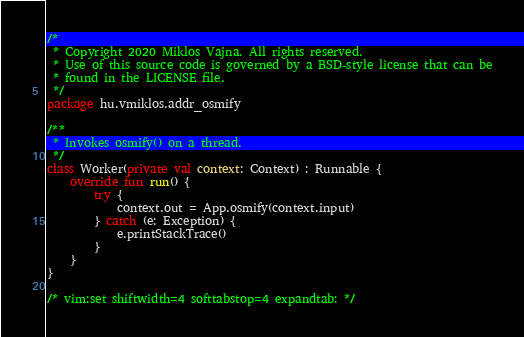<code> <loc_0><loc_0><loc_500><loc_500><_Kotlin_>/*
 * Copyright 2020 Miklos Vajna. All rights reserved.
 * Use of this source code is governed by a BSD-style license that can be
 * found in the LICENSE file.
 */
package hu.vmiklos.addr_osmify

/**
 * Invokes osmify() on a thread.
 */
class Worker(private val context: Context) : Runnable {
    override fun run() {
        try {
            context.out = App.osmify(context.input)
        } catch (e: Exception) {
            e.printStackTrace()
        }
    }
}

/* vim:set shiftwidth=4 softtabstop=4 expandtab: */
</code> 